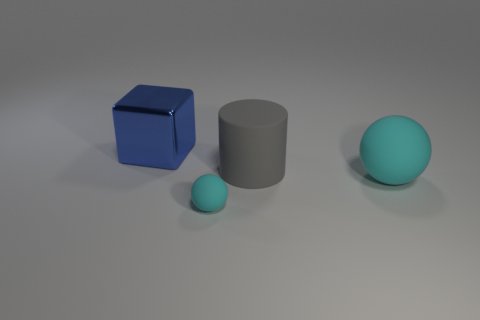Subtract all cylinders. How many objects are left? 3 Subtract 1 cubes. How many cubes are left? 0 Add 2 big green metallic spheres. How many objects exist? 6 Subtract all purple cubes. How many brown spheres are left? 0 Add 4 gray rubber cylinders. How many gray rubber cylinders are left? 5 Add 1 big blue shiny spheres. How many big blue shiny spheres exist? 1 Subtract 0 cyan blocks. How many objects are left? 4 Subtract all blue cylinders. Subtract all yellow cubes. How many cylinders are left? 1 Subtract all cyan things. Subtract all gray things. How many objects are left? 1 